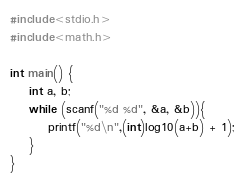<code> <loc_0><loc_0><loc_500><loc_500><_C_>#include<stdio.h>
#include<math.h>

int main() {
	int a, b;
	while (scanf("%d %d", &a, &b)){
		printf("%d\n",(int)log10(a+b) + 1);
	}
}
</code> 